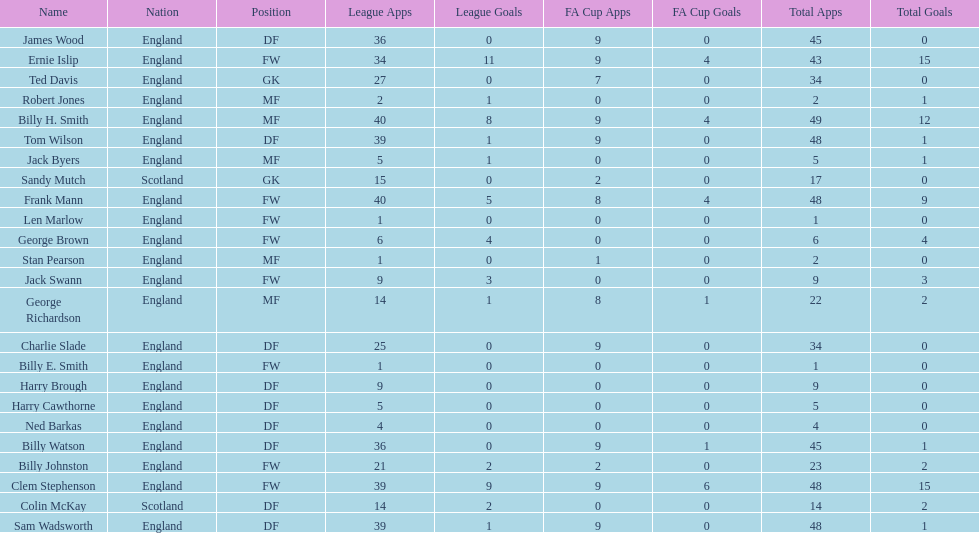What is the average number of scotland's total apps? 15.5. 